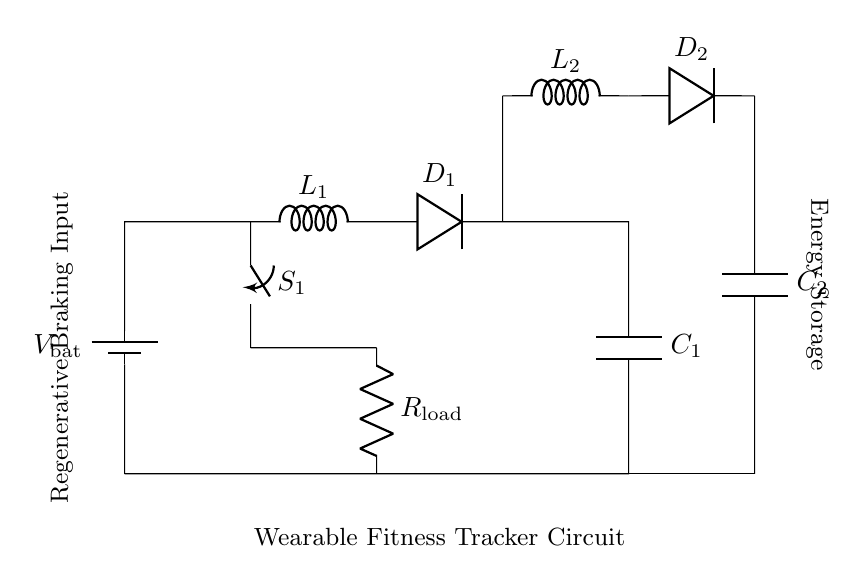What type of components are in this circuit? The circuit contains a battery, an inductor, resistors, diodes, and capacitors. These components are indicated in the diagram with standard symbols and labels, allowing for easy identification.
Answer: battery, inductor, resistor, diode, capacitor What is the function of the switch in this circuit? The switch controls the flow of current through the circuit. When closed, it allows current to flow to the load resistor, while when open, it interrupts the current flow, thereby isolating the load.
Answer: control current flow How many inductors are present in the circuit? There are two inductors labeled L1 and L2 in the circuit diagram, which can be counted directly by looking at the labeled components.
Answer: two What happens to the electrical energy stored in the capacitors? The electrical energy stored in the capacitors can be used to supply power to the load resistor when the switch is closed, converting the stored energy back into usable electrical energy for the circuit.
Answer: powers load resistor What is the purpose of the diodes in this circuit? The diodes ensure that current flows in only one direction, preventing reverse current that could discharge the capacitors or damage other components in the circuit. This behavior is critical for maintaining efficiency in energy conversion.
Answer: ensure unidirectional current What would occur if the switch is opened while the capacitors are charged? If the switch is opened while the capacitors are charged, the current flow to the load resistor is halted, causing any devices powered by the load to shut off or stop functioning. The charge in the capacitors remains until they are allowed to discharge.
Answer: current halts How does regenerative braking contribute to energy storage? Regenerative braking captures kinetic energy from movement and converts it into electrical energy. This energy is then stored in the capacitors (C1 and C2) for later use, effectively harnessing energy that would otherwise be lost.
Answer: captures kinetic energy 